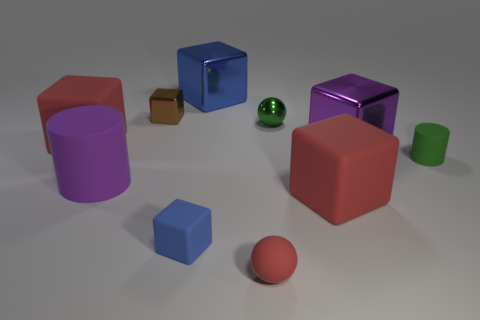Is the material of the tiny cube that is behind the green metallic ball the same as the large cylinder?
Your response must be concise. No. The thing that is both to the left of the big blue block and in front of the big matte cylinder is made of what material?
Your answer should be compact. Rubber. What size is the other block that is the same color as the tiny rubber cube?
Your answer should be very brief. Large. What is the blue block behind the large red block that is behind the small rubber cylinder made of?
Provide a succinct answer. Metal. How big is the red rubber block that is in front of the large block to the left of the blue block in front of the small metal cube?
Your answer should be very brief. Large. What number of tiny brown objects are the same material as the big purple cube?
Give a very brief answer. 1. What is the color of the large matte cube that is right of the red thing behind the purple shiny block?
Keep it short and to the point. Red. How many things are tiny blue rubber objects or small objects in front of the small green shiny thing?
Keep it short and to the point. 3. Is there a shiny ball that has the same color as the big cylinder?
Offer a terse response. No. What number of blue things are either large rubber cylinders or matte blocks?
Your answer should be compact. 1. 